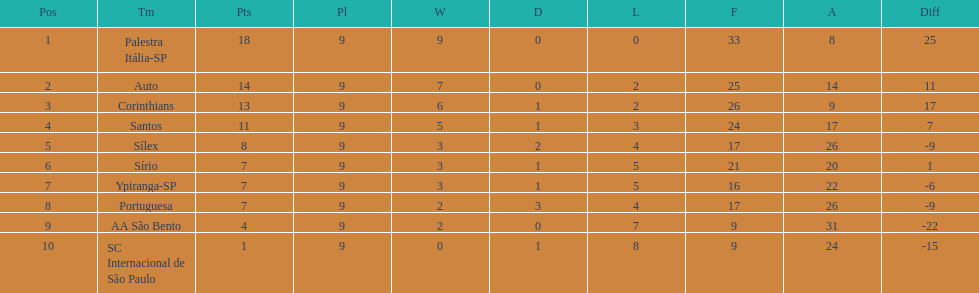Which is the only team to score 13 points in 9 games? Corinthians. 